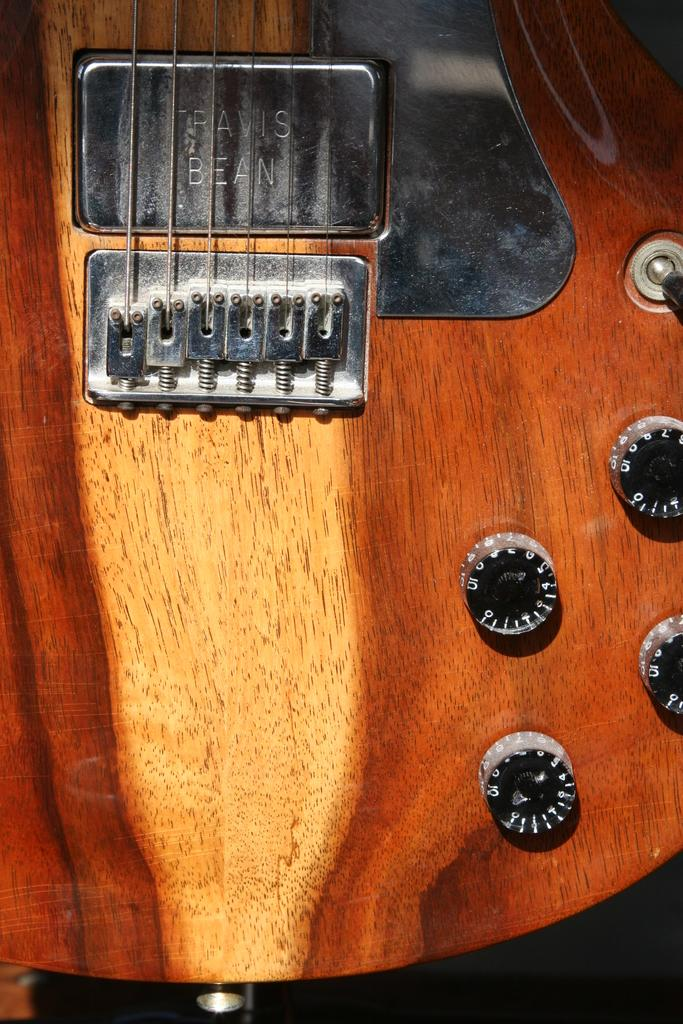What musical instrument is present in the image? There is a guitar in the image. What are the guitar's main components? The guitar has strings and tuners. What type of cart is used to transport the guitar in the image? There is no cart present in the image; the guitar is not being transported. How many ducks are playing with the guitar in the image? There are no ducks present in the image, and therefore no interaction with the guitar can be observed. 